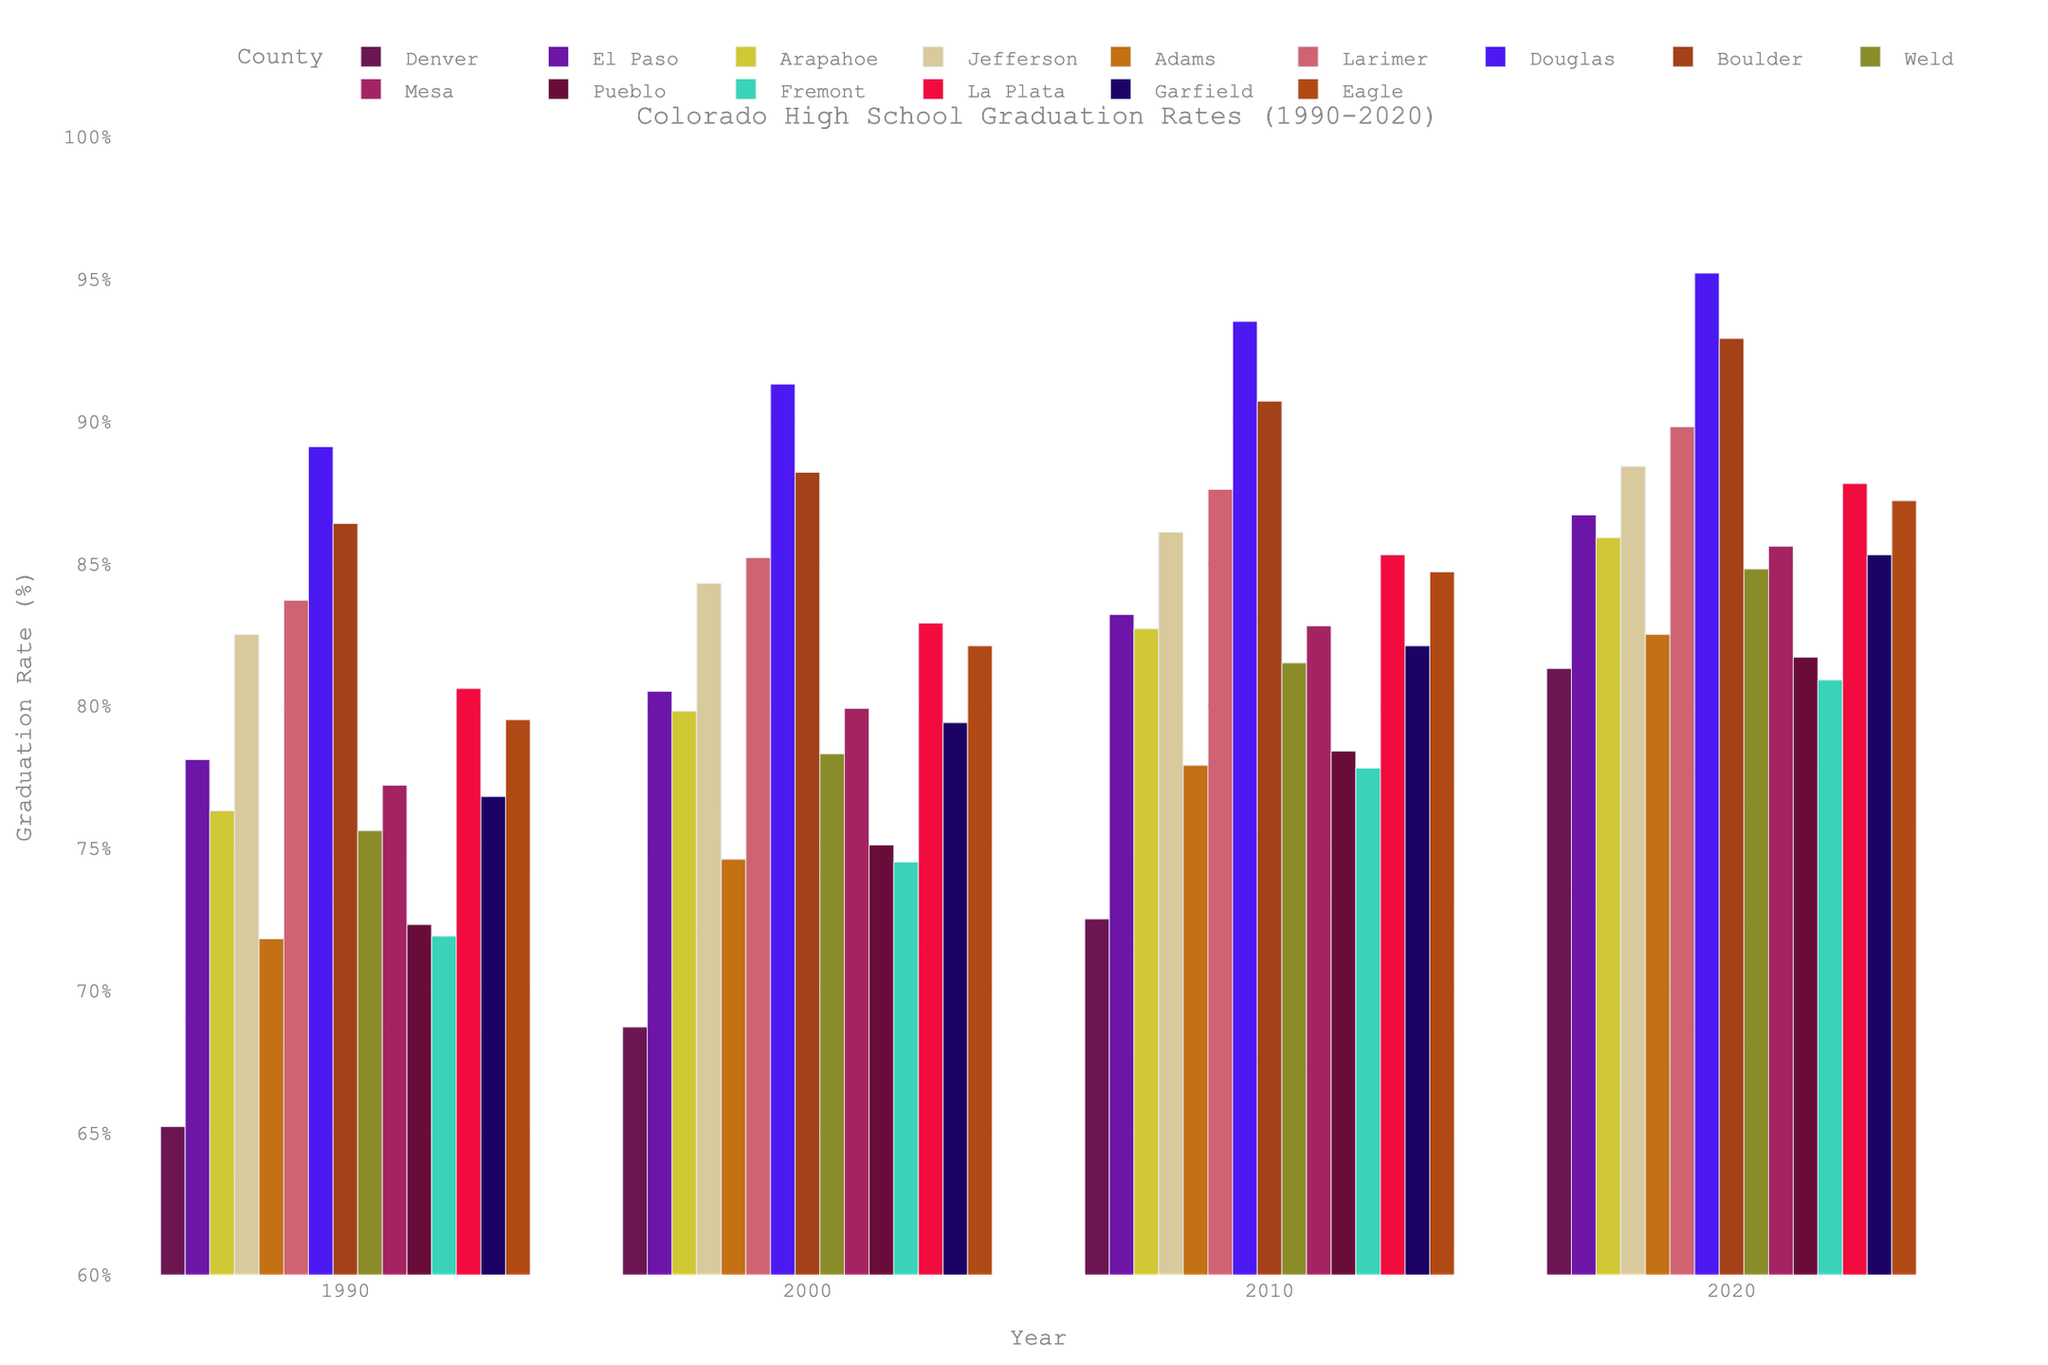What's the county with the highest graduation rate in 1990? To determine the highest graduation rate in 1990, compare the heights of the bars for each county in that year. The highest bar corresponds to Douglas County.
Answer: Douglas How does the graduation rate in Denver compare from 1990 to 2020? Compare the height of the bars for Denver in 1990 and 2020. The 1990 graduation rate is 65.2%, and the 2020 rate is 81.3%.
Answer: Increased by 16.1% Which county had the largest increase in graduation rates from 1990 to 2020? Calculate the difference in graduation rates from 1990 to 2020 for each county and compare them. Douglas County had the highest increase: 95.2% - 89.1% = 6.1%.
Answer: Douglas What's the average graduation rate in Boulder across all years displayed? Add the graduation rates of Boulder for each year and divide by the number of years. (86.4 + 88.2 + 90.7 + 92.9) / 4 = 89.55%.
Answer: 89.55% Did any county see a decrease in graduation rates over any decade? Compare the bars for each county between consecutive years. No county shows a decrease when comparing their respective bars.
Answer: No Which year saw the most counties with a graduation rate of 80% or higher? Count the number of counties with bars at 80% or higher in each year. 2020 has the most counties with graduation rates of 80% or higher.
Answer: 2020 How does the graduation rate of Arapahoe in 2000 compare to Jefferson in 2000? Compare the heights of the bars for Arapahoe and Jefferson in 2000. Arapahoe: 79.8%; Jefferson: 84.3%.
Answer: Jefferson is higher Which county shows the most consistent graduation rates over all years? Look for a county with bars of nearly equal height across all years. Boulder has consistently high rates (86.4%, 88.2%, 90.7%, 92.9%).
Answer: Boulder 